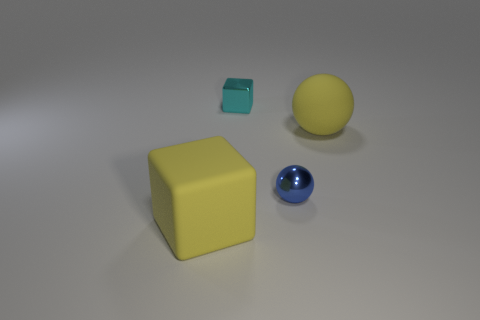Add 2 blue things. How many objects exist? 6 Subtract 0 brown cylinders. How many objects are left? 4 Subtract 2 spheres. How many spheres are left? 0 Subtract all cyan cubes. Subtract all green cylinders. How many cubes are left? 1 Subtract all blue cubes. How many green spheres are left? 0 Subtract all yellow rubber spheres. Subtract all small blue balls. How many objects are left? 2 Add 1 rubber spheres. How many rubber spheres are left? 2 Add 3 blue rubber cubes. How many blue rubber cubes exist? 3 